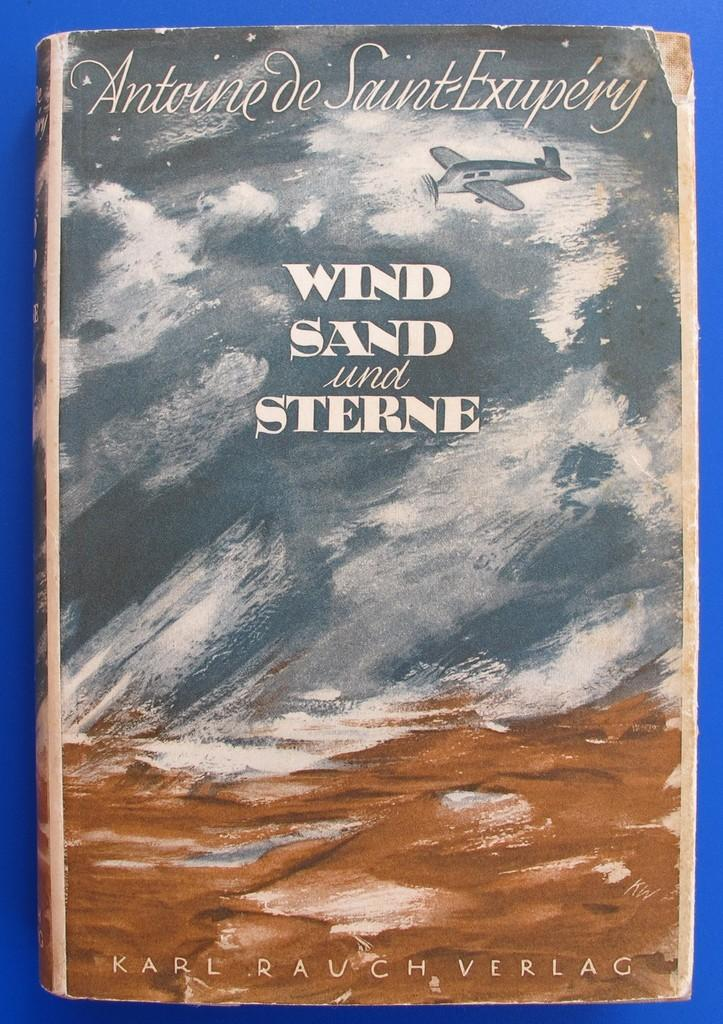<image>
Present a compact description of the photo's key features. Cover of a book named Wind Sand and Sterne by Antoine de Saint-Exupery. 